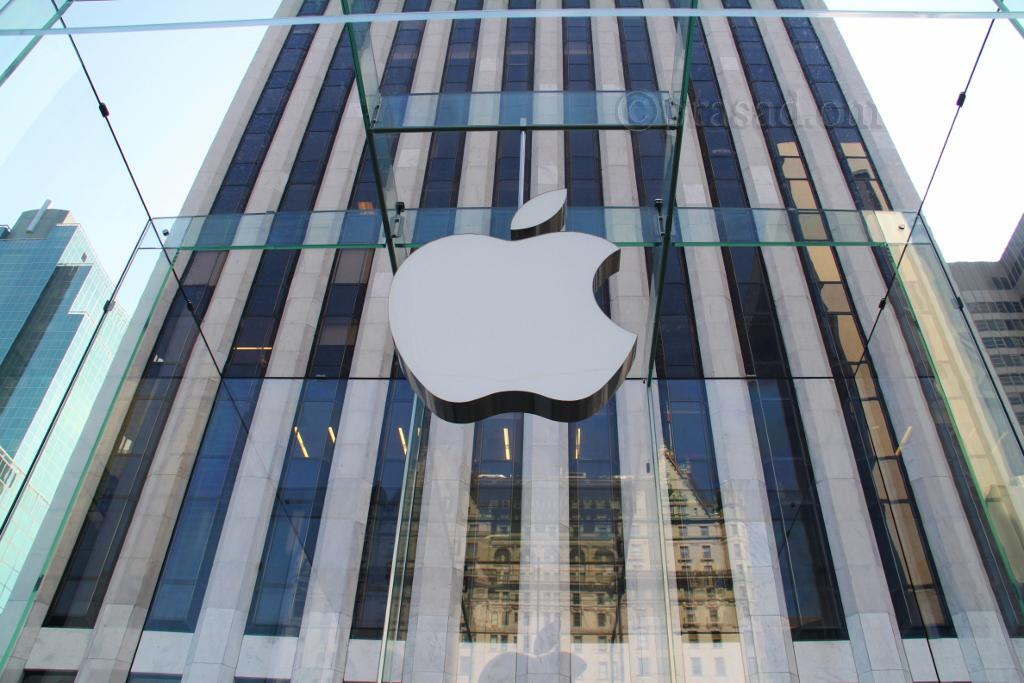What type of buildings can be seen in the image? There are skyscrapers in the image. Is there any text or symbol in the image? Yes, there is a logo in the image. What can be observed on the glass surface in the image? There is a reflection of a building on the glass in the image. What type of leaf can be seen falling from the skyscrapers in the image? There are no leaves present in the image, as it features skyscrapers and a reflection of a building on the glass. 